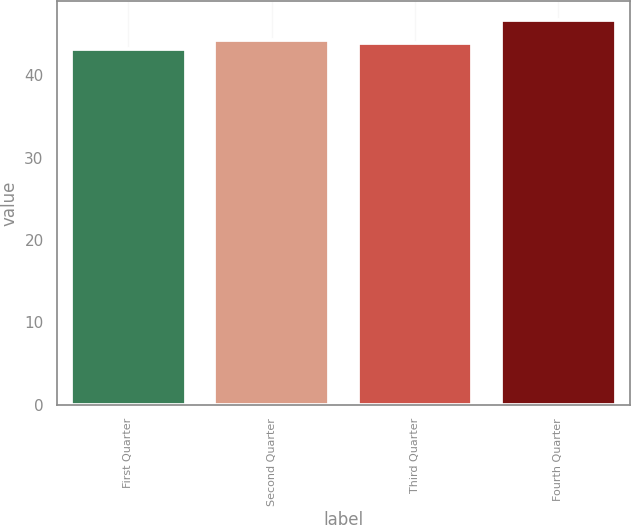Convert chart to OTSL. <chart><loc_0><loc_0><loc_500><loc_500><bar_chart><fcel>First Quarter<fcel>Second Quarter<fcel>Third Quarter<fcel>Fourth Quarter<nl><fcel>43.15<fcel>44.31<fcel>43.96<fcel>46.69<nl></chart> 